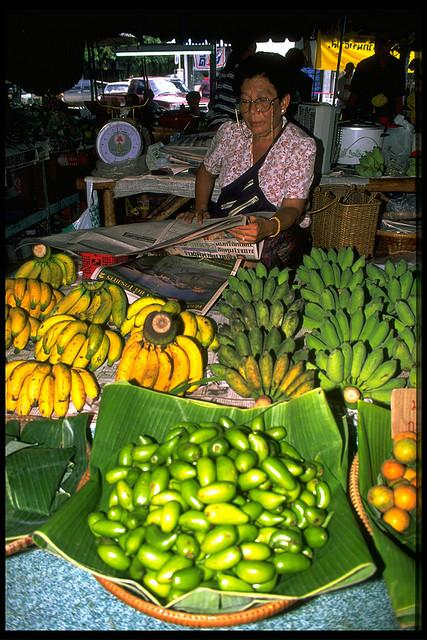What purpose does the weight in the back serve? Please explain your reasoning. measure price. It isn't really price it is measure, but the fruit so they know what to sell them as. 